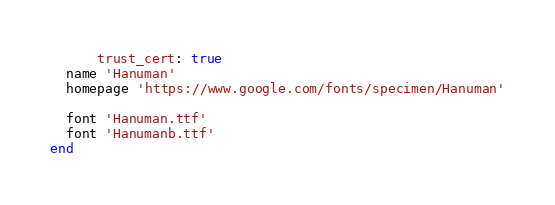<code> <loc_0><loc_0><loc_500><loc_500><_Ruby_>      trust_cert: true
  name 'Hanuman'
  homepage 'https://www.google.com/fonts/specimen/Hanuman'

  font 'Hanuman.ttf'
  font 'Hanumanb.ttf'
end
</code> 